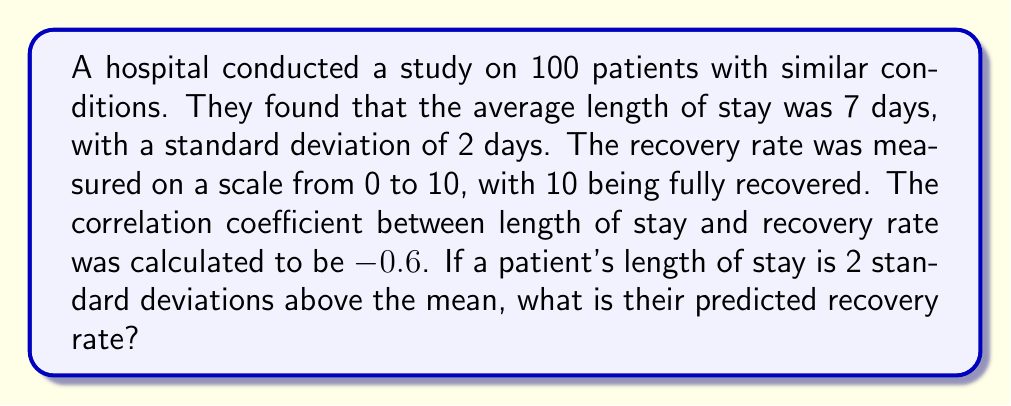Teach me how to tackle this problem. Let's approach this step-by-step:

1) First, we need to understand what the data tells us:
   - Mean length of stay: $\mu = 7$ days
   - Standard deviation of length of stay: $\sigma = 2$ days
   - Correlation coefficient: $r = -0.6$

2) The patient's length of stay is 2 standard deviations above the mean:
   $x = \mu + 2\sigma = 7 + 2(2) = 11$ days

3) To predict the recovery rate, we'll use the regression equation:
   $$y = \bar{y} + r\frac{s_y}{s_x}(x - \bar{x})$$
   where $y$ is the predicted recovery rate, $\bar{y}$ is the mean recovery rate, $s_y$ is the standard deviation of recovery rates, $s_x$ is the standard deviation of length of stay, $x$ is the given length of stay, and $\bar{x}$ is the mean length of stay.

4) We're not given $\bar{y}$ or $s_y$, but we can still solve this problem by expressing the answer in terms of these unknown values:

   $$y = \bar{y} + (-0.6)\frac{s_y}{2}(11 - 7)$$

5) Simplify:
   $$y = \bar{y} - 0.6\frac{s_y}{2}(4) = \bar{y} - 1.2s_y$$

6) This means the predicted recovery rate is 1.2 standard deviations below the mean recovery rate.

7) Given the recovery rate scale of 0 to 10, we can interpret this as a relatively poor recovery rate compared to the average.
Answer: $\bar{y} - 1.2s_y$ 